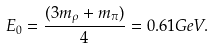Convert formula to latex. <formula><loc_0><loc_0><loc_500><loc_500>E _ { 0 } = \frac { ( 3 m _ { \rho } + m _ { \pi } ) } { 4 } = 0 . 6 1 G e V .</formula> 